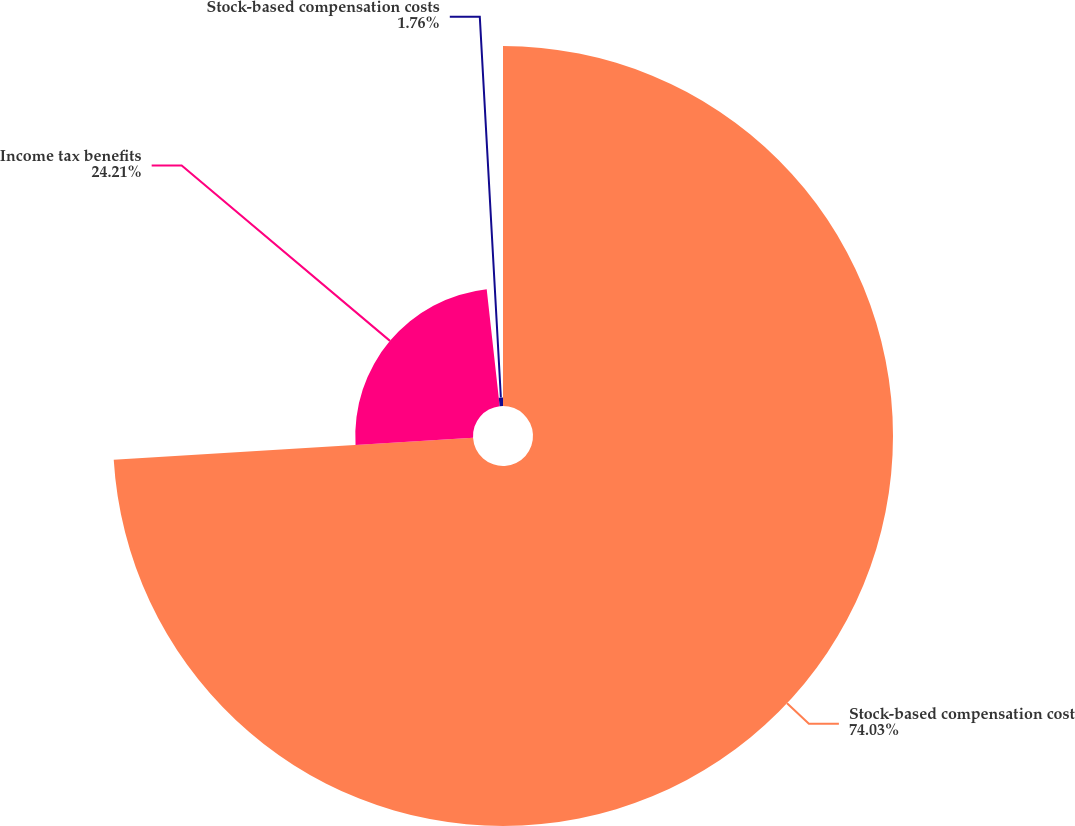Convert chart. <chart><loc_0><loc_0><loc_500><loc_500><pie_chart><fcel>Stock-based compensation cost<fcel>Income tax benefits<fcel>Stock-based compensation costs<nl><fcel>74.03%<fcel>24.21%<fcel>1.76%<nl></chart> 